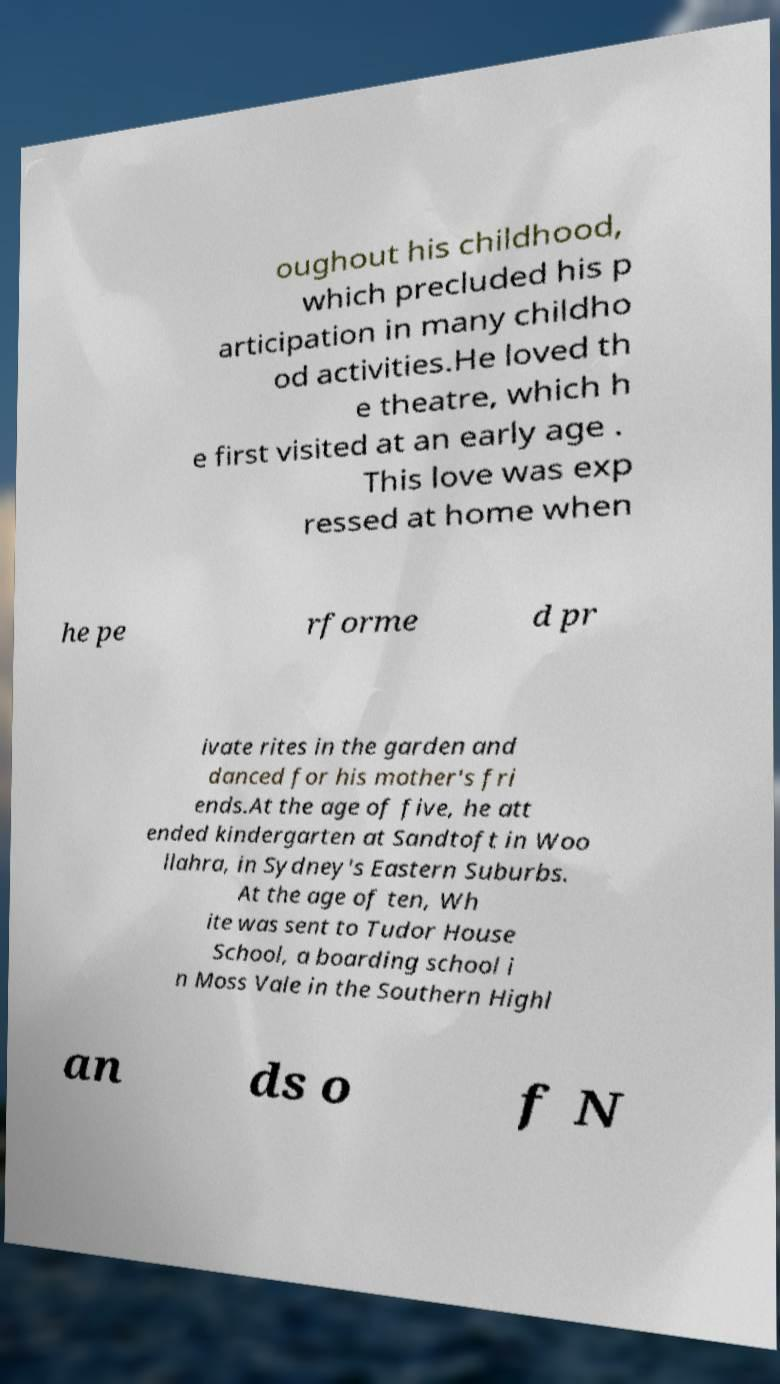Please read and relay the text visible in this image. What does it say? oughout his childhood, which precluded his p articipation in many childho od activities.He loved th e theatre, which h e first visited at an early age . This love was exp ressed at home when he pe rforme d pr ivate rites in the garden and danced for his mother's fri ends.At the age of five, he att ended kindergarten at Sandtoft in Woo llahra, in Sydney's Eastern Suburbs. At the age of ten, Wh ite was sent to Tudor House School, a boarding school i n Moss Vale in the Southern Highl an ds o f N 